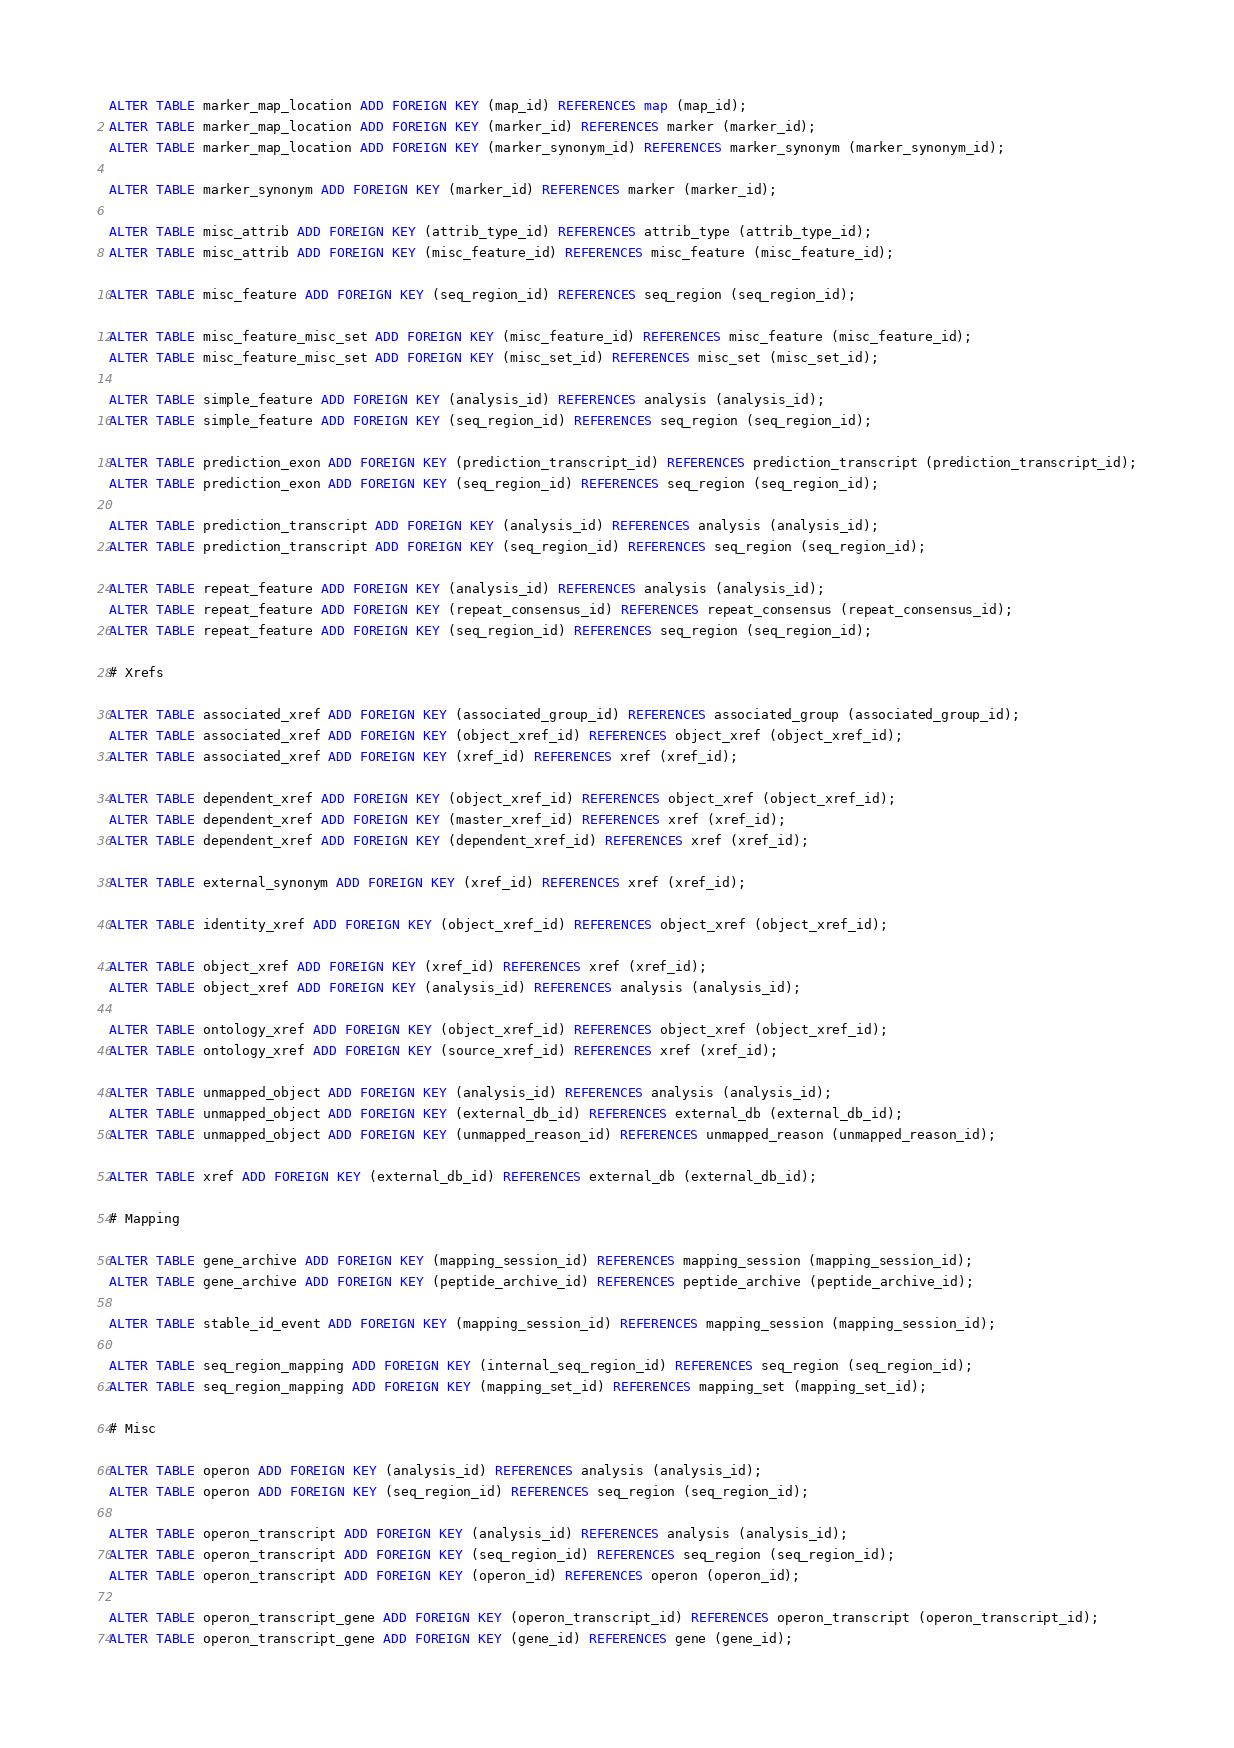<code> <loc_0><loc_0><loc_500><loc_500><_SQL_>
ALTER TABLE marker_map_location ADD FOREIGN KEY (map_id) REFERENCES map (map_id);
ALTER TABLE marker_map_location ADD FOREIGN KEY (marker_id) REFERENCES marker (marker_id);
ALTER TABLE marker_map_location ADD FOREIGN KEY (marker_synonym_id) REFERENCES marker_synonym (marker_synonym_id);

ALTER TABLE marker_synonym ADD FOREIGN KEY (marker_id) REFERENCES marker (marker_id);

ALTER TABLE misc_attrib ADD FOREIGN KEY (attrib_type_id) REFERENCES attrib_type (attrib_type_id);
ALTER TABLE misc_attrib ADD FOREIGN KEY (misc_feature_id) REFERENCES misc_feature (misc_feature_id);

ALTER TABLE misc_feature ADD FOREIGN KEY (seq_region_id) REFERENCES seq_region (seq_region_id);

ALTER TABLE misc_feature_misc_set ADD FOREIGN KEY (misc_feature_id) REFERENCES misc_feature (misc_feature_id);
ALTER TABLE misc_feature_misc_set ADD FOREIGN KEY (misc_set_id) REFERENCES misc_set (misc_set_id);

ALTER TABLE simple_feature ADD FOREIGN KEY (analysis_id) REFERENCES analysis (analysis_id);
ALTER TABLE simple_feature ADD FOREIGN KEY (seq_region_id) REFERENCES seq_region (seq_region_id);

ALTER TABLE prediction_exon ADD FOREIGN KEY (prediction_transcript_id) REFERENCES prediction_transcript (prediction_transcript_id);
ALTER TABLE prediction_exon ADD FOREIGN KEY (seq_region_id) REFERENCES seq_region (seq_region_id);

ALTER TABLE prediction_transcript ADD FOREIGN KEY (analysis_id) REFERENCES analysis (analysis_id);
ALTER TABLE prediction_transcript ADD FOREIGN KEY (seq_region_id) REFERENCES seq_region (seq_region_id);

ALTER TABLE repeat_feature ADD FOREIGN KEY (analysis_id) REFERENCES analysis (analysis_id);
ALTER TABLE repeat_feature ADD FOREIGN KEY (repeat_consensus_id) REFERENCES repeat_consensus (repeat_consensus_id);
ALTER TABLE repeat_feature ADD FOREIGN KEY (seq_region_id) REFERENCES seq_region (seq_region_id);

# Xrefs

ALTER TABLE associated_xref ADD FOREIGN KEY (associated_group_id) REFERENCES associated_group (associated_group_id);
ALTER TABLE associated_xref ADD FOREIGN KEY (object_xref_id) REFERENCES object_xref (object_xref_id);
ALTER TABLE associated_xref ADD FOREIGN KEY (xref_id) REFERENCES xref (xref_id);

ALTER TABLE dependent_xref ADD FOREIGN KEY (object_xref_id) REFERENCES object_xref (object_xref_id);
ALTER TABLE dependent_xref ADD FOREIGN KEY (master_xref_id) REFERENCES xref (xref_id);
ALTER TABLE dependent_xref ADD FOREIGN KEY (dependent_xref_id) REFERENCES xref (xref_id);

ALTER TABLE external_synonym ADD FOREIGN KEY (xref_id) REFERENCES xref (xref_id);

ALTER TABLE identity_xref ADD FOREIGN KEY (object_xref_id) REFERENCES object_xref (object_xref_id);

ALTER TABLE object_xref ADD FOREIGN KEY (xref_id) REFERENCES xref (xref_id);
ALTER TABLE object_xref ADD FOREIGN KEY (analysis_id) REFERENCES analysis (analysis_id);

ALTER TABLE ontology_xref ADD FOREIGN KEY (object_xref_id) REFERENCES object_xref (object_xref_id);
ALTER TABLE ontology_xref ADD FOREIGN KEY (source_xref_id) REFERENCES xref (xref_id);

ALTER TABLE unmapped_object ADD FOREIGN KEY (analysis_id) REFERENCES analysis (analysis_id);
ALTER TABLE unmapped_object ADD FOREIGN KEY (external_db_id) REFERENCES external_db (external_db_id);
ALTER TABLE unmapped_object ADD FOREIGN KEY (unmapped_reason_id) REFERENCES unmapped_reason (unmapped_reason_id);

ALTER TABLE xref ADD FOREIGN KEY (external_db_id) REFERENCES external_db (external_db_id);

# Mapping

ALTER TABLE gene_archive ADD FOREIGN KEY (mapping_session_id) REFERENCES mapping_session (mapping_session_id);
ALTER TABLE gene_archive ADD FOREIGN KEY (peptide_archive_id) REFERENCES peptide_archive (peptide_archive_id);

ALTER TABLE stable_id_event ADD FOREIGN KEY (mapping_session_id) REFERENCES mapping_session (mapping_session_id);

ALTER TABLE seq_region_mapping ADD FOREIGN KEY (internal_seq_region_id) REFERENCES seq_region (seq_region_id);
ALTER TABLE seq_region_mapping ADD FOREIGN KEY (mapping_set_id) REFERENCES mapping_set (mapping_set_id);

# Misc

ALTER TABLE operon ADD FOREIGN KEY (analysis_id) REFERENCES analysis (analysis_id);
ALTER TABLE operon ADD FOREIGN KEY (seq_region_id) REFERENCES seq_region (seq_region_id);

ALTER TABLE operon_transcript ADD FOREIGN KEY (analysis_id) REFERENCES analysis (analysis_id);
ALTER TABLE operon_transcript ADD FOREIGN KEY (seq_region_id) REFERENCES seq_region (seq_region_id); 
ALTER TABLE operon_transcript ADD FOREIGN KEY (operon_id) REFERENCES operon (operon_id);

ALTER TABLE operon_transcript_gene ADD FOREIGN KEY (operon_transcript_id) REFERENCES operon_transcript (operon_transcript_id);
ALTER TABLE operon_transcript_gene ADD FOREIGN KEY (gene_id) REFERENCES gene (gene_id);









</code> 